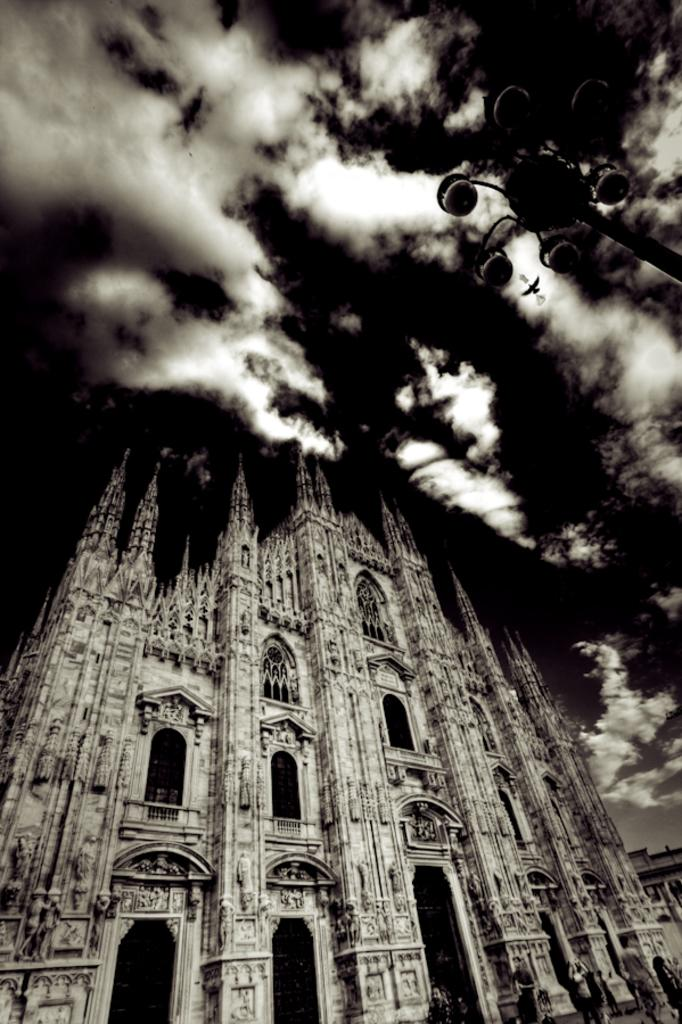What is the main structure in the picture? There is a building in the picture. What can be seen on the right top of the picture? There is a pole with street lights on the right top of the picture. What is visible at the top of the picture? The sky is visible at the top of the picture. What is the color scheme of the picture? The picture is in black and white. What action is the building taking in the picture? Buildings do not take actions; they are inanimate structures. 